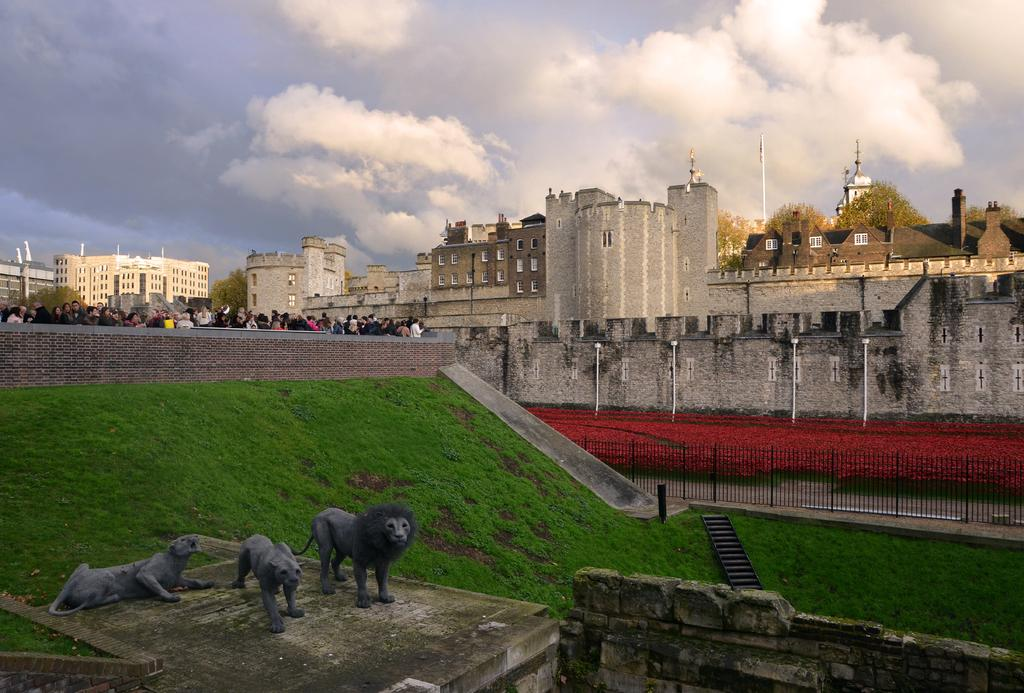What type of structures can be seen in the image? There are buildings in the image. What objects are held by the people in the image? There are scepters in the image. What type of vegetation is visible in the image? There is grass visible in the image. What are the people in the image doing? There are people standing in one place in the image. What type of vegetable is being used as a roll in the image? There is no vegetable being used as a roll in the image. 